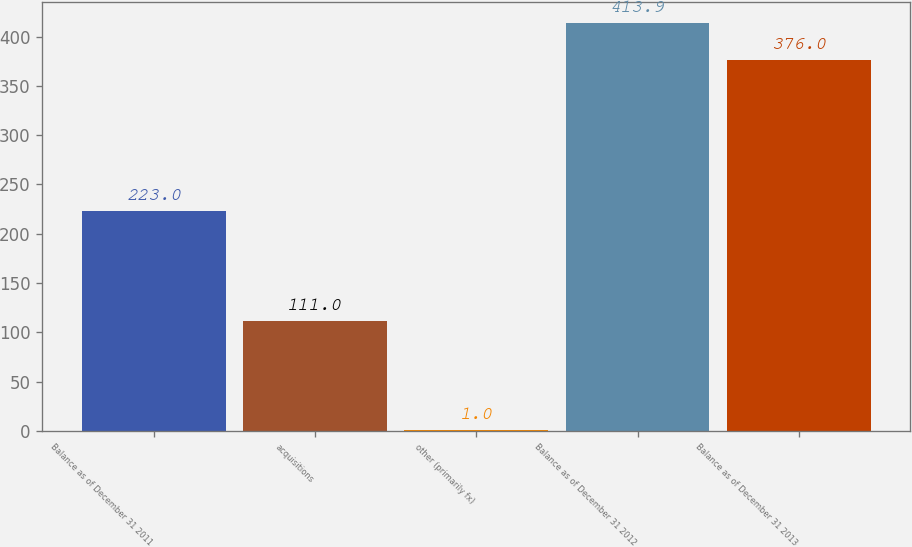Convert chart to OTSL. <chart><loc_0><loc_0><loc_500><loc_500><bar_chart><fcel>Balance as of December 31 2011<fcel>acquisitions<fcel>other (primarily fx)<fcel>Balance as of December 31 2012<fcel>Balance as of December 31 2013<nl><fcel>223<fcel>111<fcel>1<fcel>413.9<fcel>376<nl></chart> 